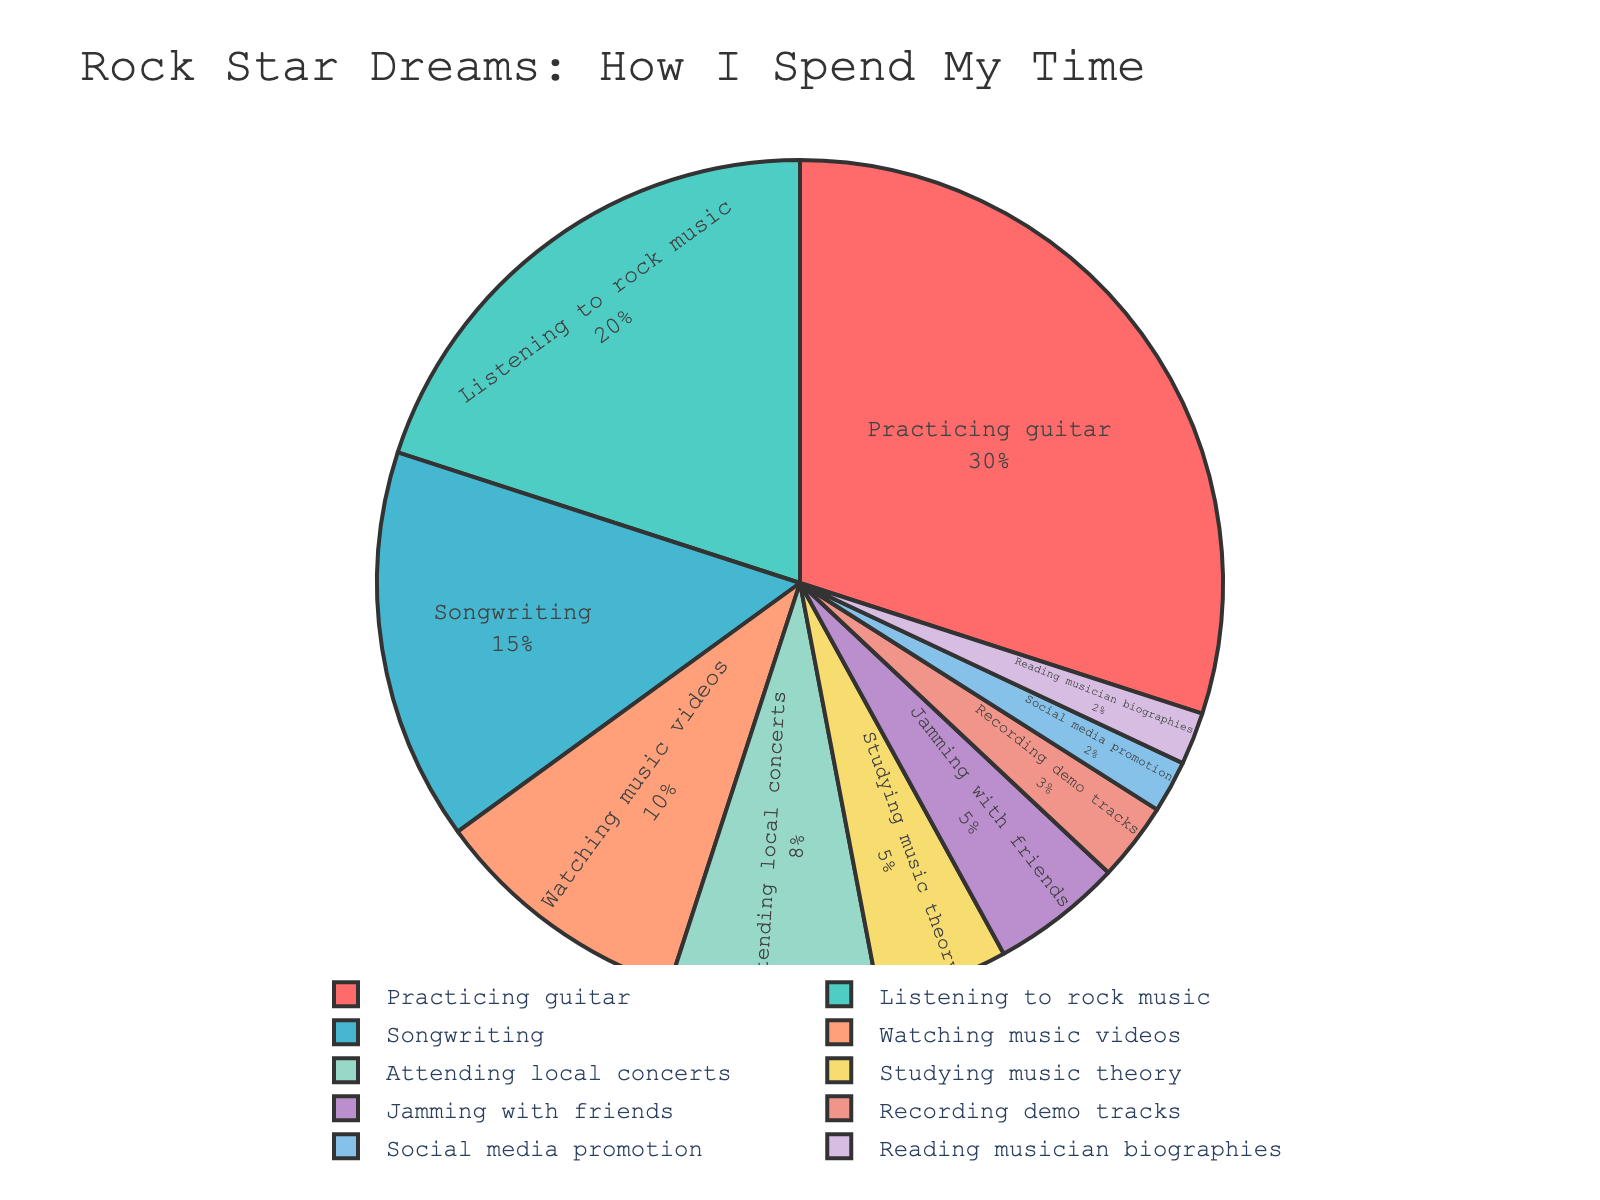Which activity takes up the most percentage of time? The slice labeled "Practicing guitar" is the largest, and it represents 30% of the time spent.
Answer: Practicing guitar What is the combined percentage of time spent on songwriting and recording demo tracks? According to the pie chart, songwriting takes up 15% and recording demo tracks takes up 3%. Adding these two percentages together gives 15% + 3% = 18%.
Answer: 18% How much more time is spent practicing guitar compared to attending local concerts? The time spent practicing guitar is 30%, while attending local concerts is 8%. The difference between the two is 30% - 8% = 22%.
Answer: 22% Which activities account for the smallest percentage of time spent? The slices labeled "Social media promotion" and "Reading musician biographies" each represent 2% of the time.
Answer: Social media promotion and Reading musician biographies What percentage of time is spent on jamming with friends and studying music theory combined? Jamming with friends takes up 5% and studying music theory also takes up 5%. Adding these two together gives 5% + 5% = 10%.
Answer: 10% Is more time spent listening to rock music or watching music videos? According to the pie chart, listening to rock music takes up 20%, while watching music videos takes up 10%. Therefore, more time is spent listening to rock music.
Answer: Listening to rock music Which activities contribute to over 50% of the time spent? The pie chart shows that practicing guitar (30%) and listening to rock music (20%) together account for 30% + 20% = 50%. Adding any other activity would surpass 50%.
Answer: Practicing guitar and Listening to rock music How much time in percentage is spent on attending local concerts compared to recording demo tracks? Attending local concerts takes up 8%, while recording demo tracks takes up 3%. Therefore, the time spent on attending local concerts is 8%/3% ≈ 2.67 times that of recording demo tracks.
Answer: 2.67 times 